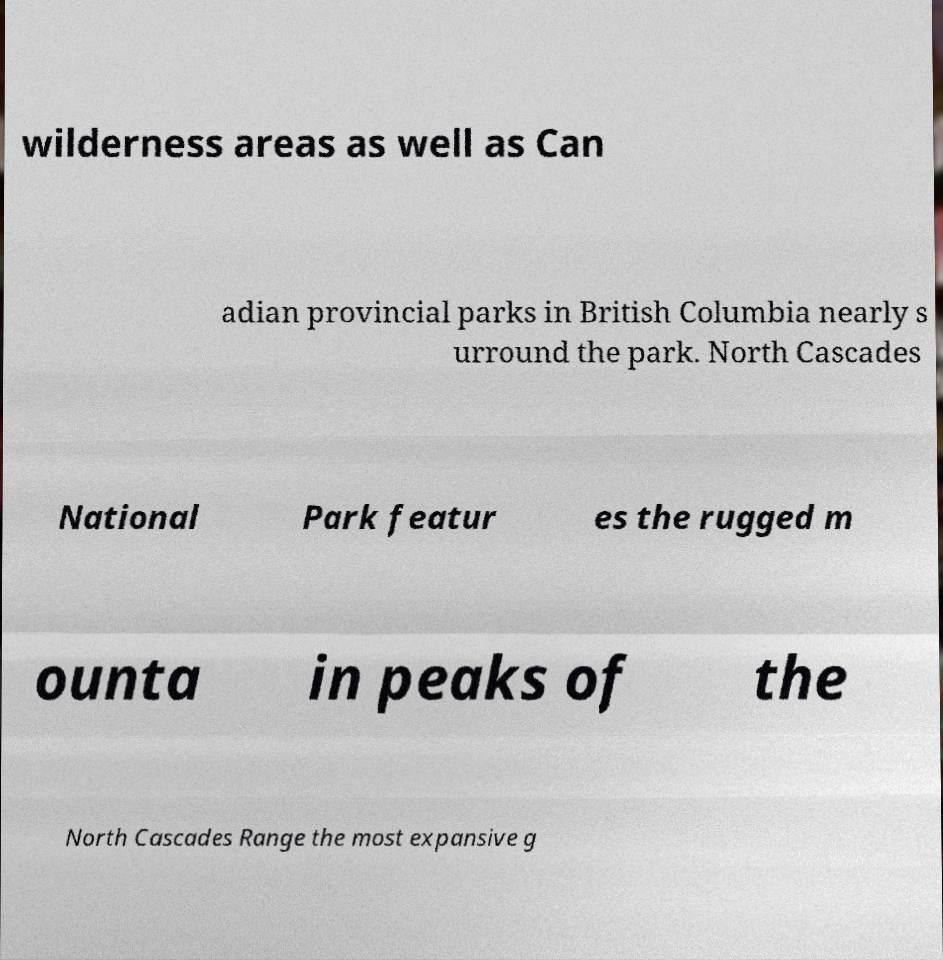I need the written content from this picture converted into text. Can you do that? wilderness areas as well as Can adian provincial parks in British Columbia nearly s urround the park. North Cascades National Park featur es the rugged m ounta in peaks of the North Cascades Range the most expansive g 